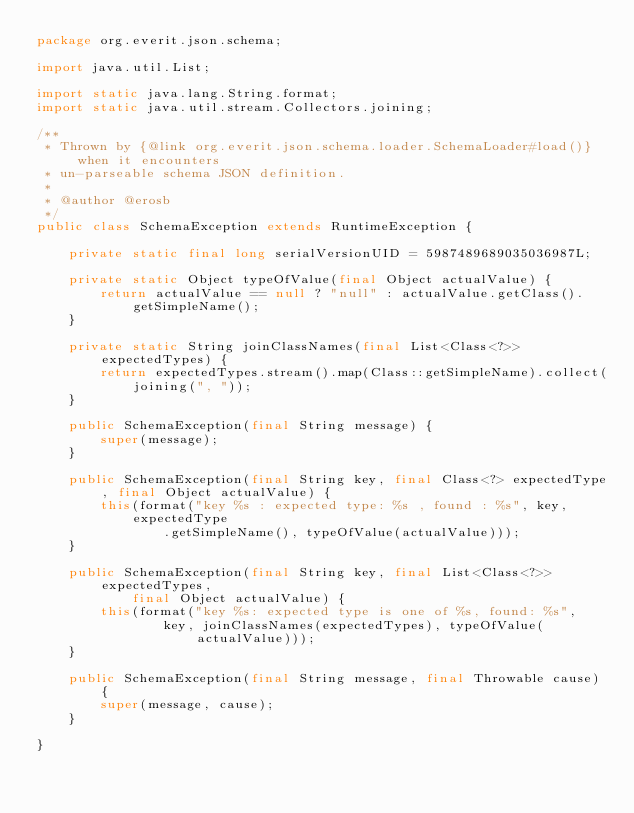<code> <loc_0><loc_0><loc_500><loc_500><_Java_>package org.everit.json.schema;

import java.util.List;

import static java.lang.String.format;
import static java.util.stream.Collectors.joining;

/**
 * Thrown by {@link org.everit.json.schema.loader.SchemaLoader#load()} when it encounters
 * un-parseable schema JSON definition.
 *
 * @author @erosb
 */
public class SchemaException extends RuntimeException {

    private static final long serialVersionUID = 5987489689035036987L;

    private static Object typeOfValue(final Object actualValue) {
        return actualValue == null ? "null" : actualValue.getClass().getSimpleName();
    }

    private static String joinClassNames(final List<Class<?>> expectedTypes) {
        return expectedTypes.stream().map(Class::getSimpleName).collect(joining(", "));
    }

    public SchemaException(final String message) {
        super(message);
    }

    public SchemaException(final String key, final Class<?> expectedType, final Object actualValue) {
        this(format("key %s : expected type: %s , found : %s", key, expectedType
                .getSimpleName(), typeOfValue(actualValue)));
    }

    public SchemaException(final String key, final List<Class<?>> expectedTypes,
            final Object actualValue) {
        this(format("key %s: expected type is one of %s, found: %s",
                key, joinClassNames(expectedTypes), typeOfValue(actualValue)));
    }

    public SchemaException(final String message, final Throwable cause) {
        super(message, cause);
    }

}
</code> 